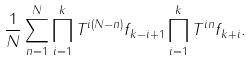<formula> <loc_0><loc_0><loc_500><loc_500>\frac { 1 } { N } \sum _ { n = 1 } ^ { N } \prod _ { i = 1 } ^ { k } T ^ { i ( N - n ) } f _ { k - i + 1 } \prod _ { i = 1 } ^ { k } T ^ { i n } f _ { k + i } .</formula> 